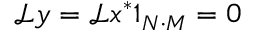<formula> <loc_0><loc_0><loc_500><loc_500>\mathcal { L } y = \mathcal { L } x ^ { * } 1 _ { N \cdot M } = 0</formula> 